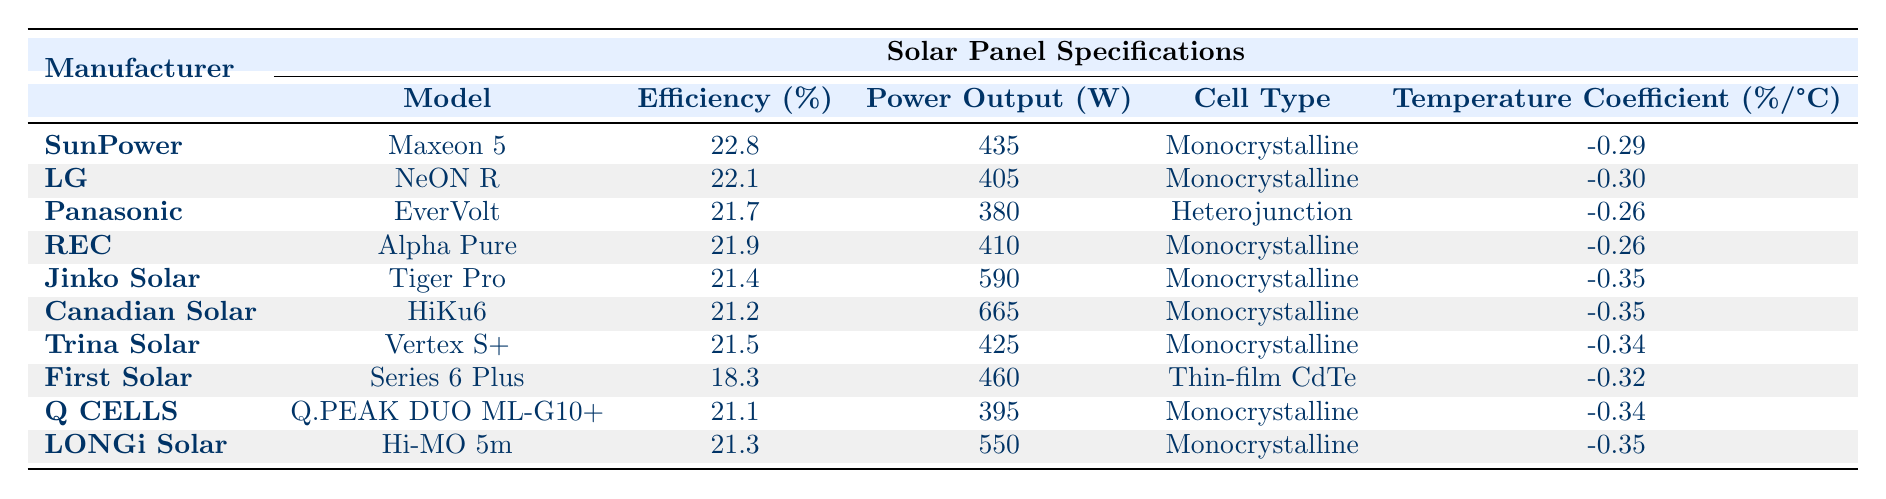What is the efficiency of the SunPower Maxeon 5 model? The table lists the efficiency of the SunPower Maxeon 5 model directly under the "Efficiency (%)" column. The value is 22.8.
Answer: 22.8 Which manufacturer's panel has the highest power output? To find the manufacturer's panel with the highest power output, we compare the "Power Output (W)" values across all models. The Canadian Solar HiKu6 has the highest power output at 665 W.
Answer: Canadian Solar What is the average efficiency of the panels from manufacturers based in China? The panels from China in the table are from Jinko Solar, Trina Solar, and LONGi Solar with efficiencies of 21.4, 21.5, and 21.3, respectively. The average is calculated as (21.4 + 21.5 + 21.3) / 3 = 21.4.
Answer: 21.4 Does LG produce a model with a higher efficiency than 22%? From the data, LG's NeON R has an efficiency of 22.1%, which is indeed higher than 22%. Thus, the statement is true.
Answer: Yes Which model has the second lowest efficiency and what is its efficiency? The efficiencies listed are ordered as follows: 22.8, 22.1, 21.9, 21.7, 21.5, 21.4, 21.3, 21.2, 21.1, and 18.3. The second lowest efficiency belongs to Jinko Solar's Tiger Pro with an efficiency of 21.4%.
Answer: 21.4 What is the warranty period offered by Panasonic for the EverVolt model? The table specifies that the warranty period for the Panasonic EverVolt model is 25 years, as indicated in the "Warranty (Years)" column.
Answer: 25 Is the temperature coefficient of the REC Alpha Pure lower than that of the LG NeON R? The temperature coefficient of REC Alpha Pure is -0.26, while that of LG NeON R is -0.30. Since -0.26 is higher than -0.30, thus it is NOT lower.
Answer: No What is the total power output of the three panels with the highest efficiency? The panels with the highest efficiencies are SunPower Maxeon 5, LG NeON R, and REC Alpha Pure, with power outputs of 435 W, 405 W, and 410 W, respectively. The total power output is calculated as 435 + 405 + 410 = 1250 W.
Answer: 1250 